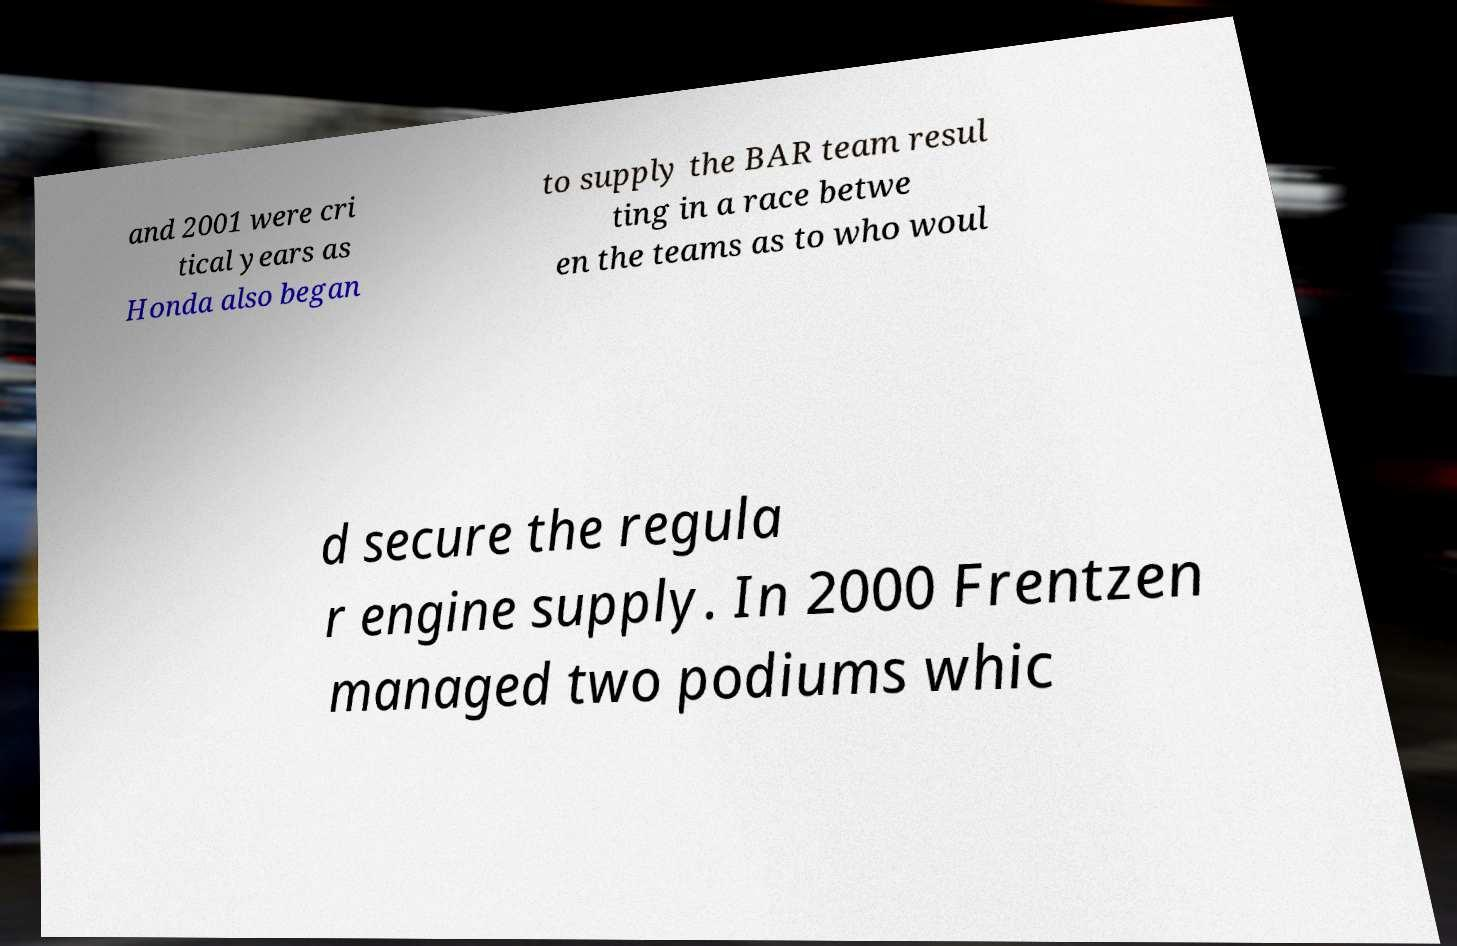Can you accurately transcribe the text from the provided image for me? and 2001 were cri tical years as Honda also began to supply the BAR team resul ting in a race betwe en the teams as to who woul d secure the regula r engine supply. In 2000 Frentzen managed two podiums whic 